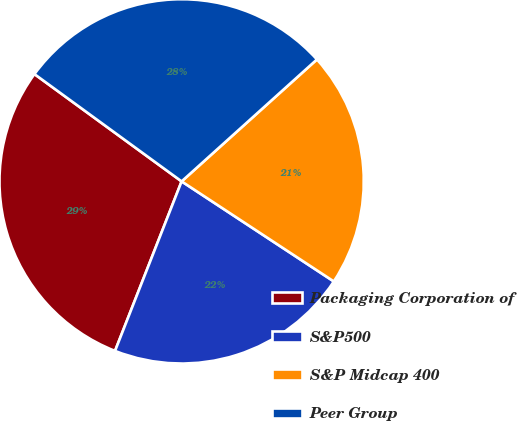Convert chart. <chart><loc_0><loc_0><loc_500><loc_500><pie_chart><fcel>Packaging Corporation of<fcel>S&P500<fcel>S&P Midcap 400<fcel>Peer Group<nl><fcel>29.07%<fcel>21.7%<fcel>20.93%<fcel>28.3%<nl></chart> 